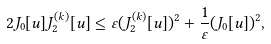<formula> <loc_0><loc_0><loc_500><loc_500>2 J _ { 0 } [ u ] J _ { 2 } ^ { ( k ) } [ u ] \leq \varepsilon ( J _ { 2 } ^ { ( k ) } [ u ] ) ^ { 2 } + \frac { 1 } { \varepsilon } ( J _ { 0 } [ u ] ) ^ { 2 } ,</formula> 